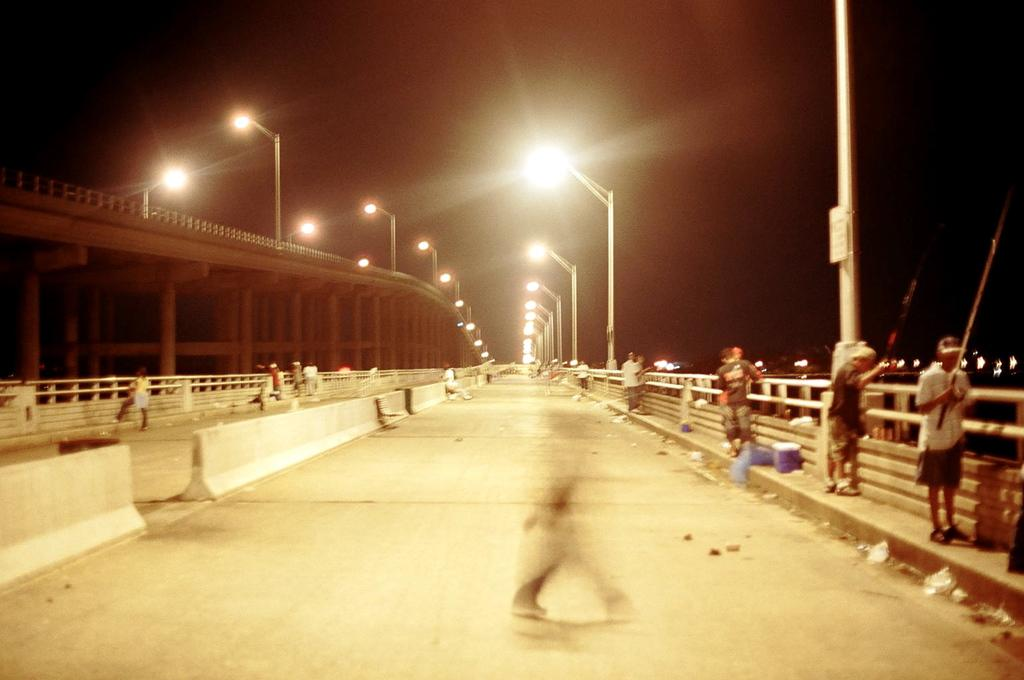What is the main structure in the center of the image? There is a bridge in the center of the image. What can be seen on the right side of the image? There are people standing on the right side of the image. What is visible in the background of the image? There are poles, lights, and the sky visible in the background of the image. What type of wilderness can be seen in the background of the image? There is no wilderness present in the image; it features a bridge, people, poles, lights, and the sky. What country is the feast taking place in, as depicted in the image? There is no feast or country mentioned in the image; it only shows a bridge, people, poles, lights, and the sky. 